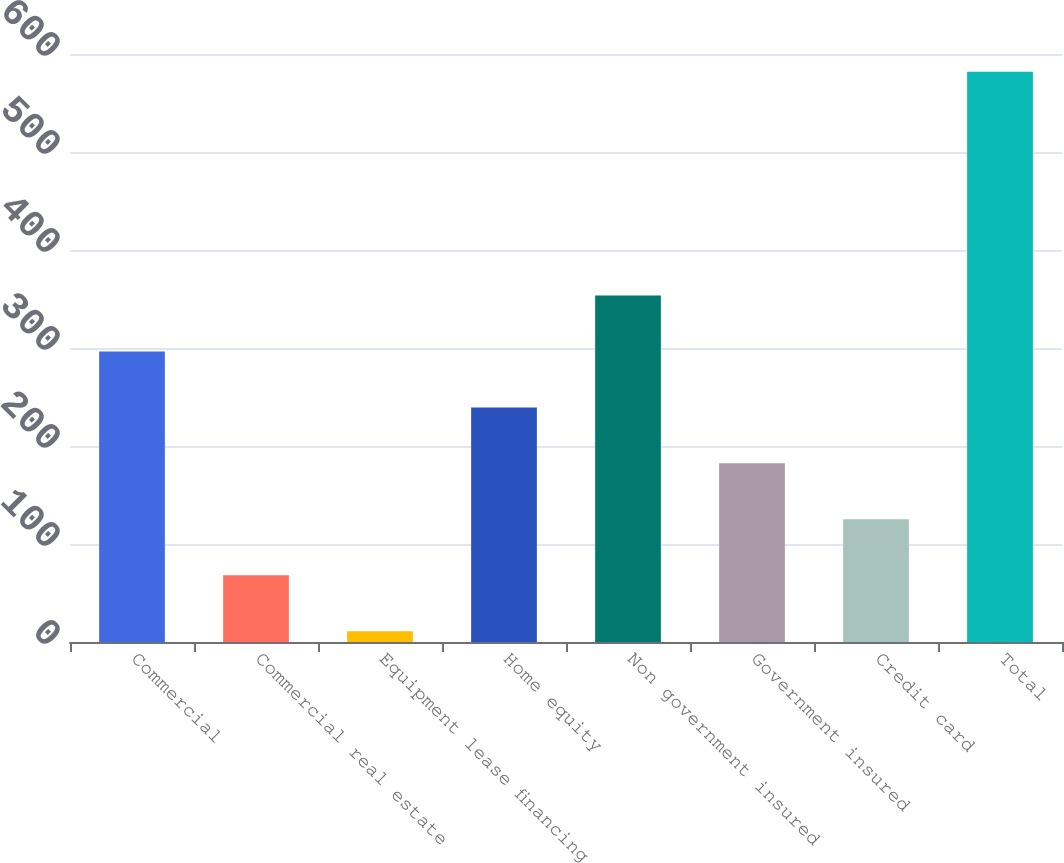<chart> <loc_0><loc_0><loc_500><loc_500><bar_chart><fcel>Commercial<fcel>Commercial real estate<fcel>Equipment lease financing<fcel>Home equity<fcel>Non government insured<fcel>Government insured<fcel>Credit card<fcel>Total<nl><fcel>296.5<fcel>68.1<fcel>11<fcel>239.4<fcel>353.6<fcel>182.3<fcel>125.2<fcel>582<nl></chart> 